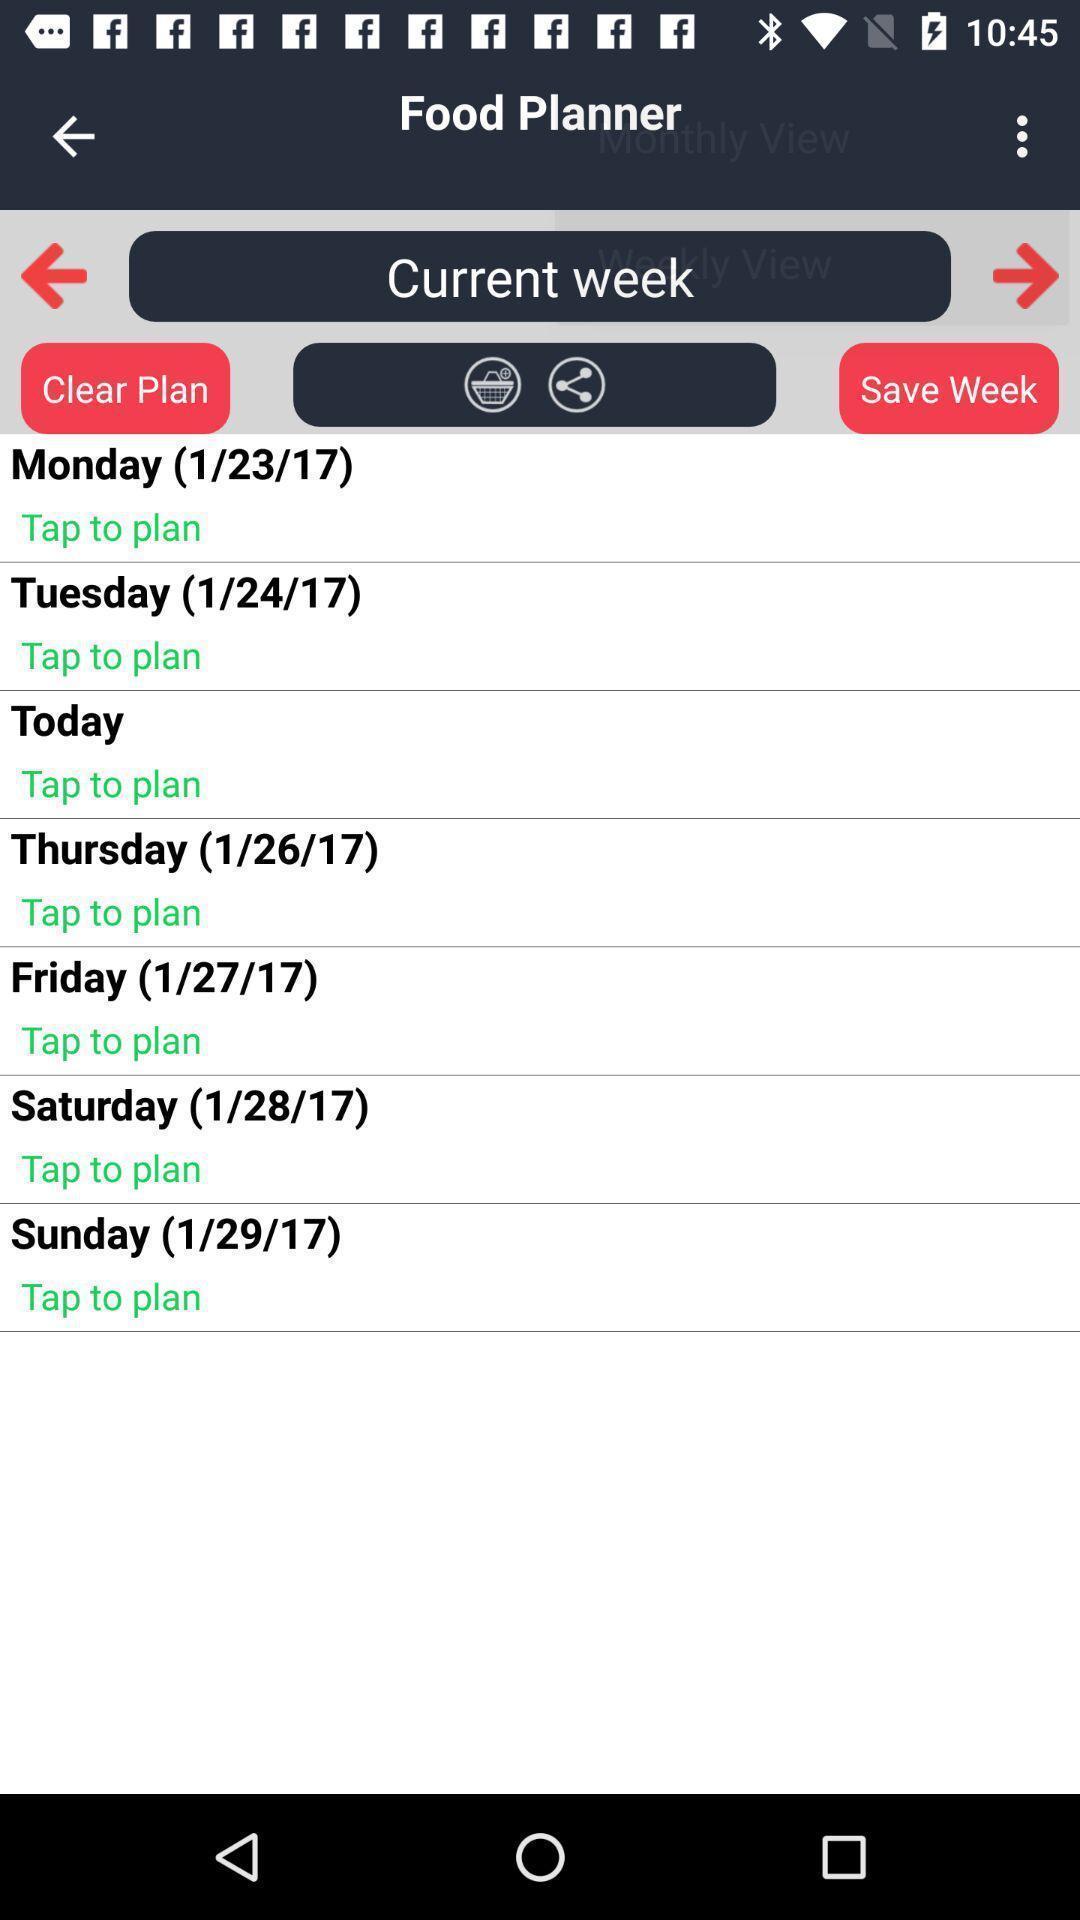Describe the visual elements of this screenshot. Screen display multiple days to plan food. 